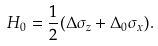<formula> <loc_0><loc_0><loc_500><loc_500>H _ { 0 } = \frac { 1 } { 2 } ( \Delta \sigma _ { z } + \Delta _ { 0 } \sigma _ { x } ) .</formula> 